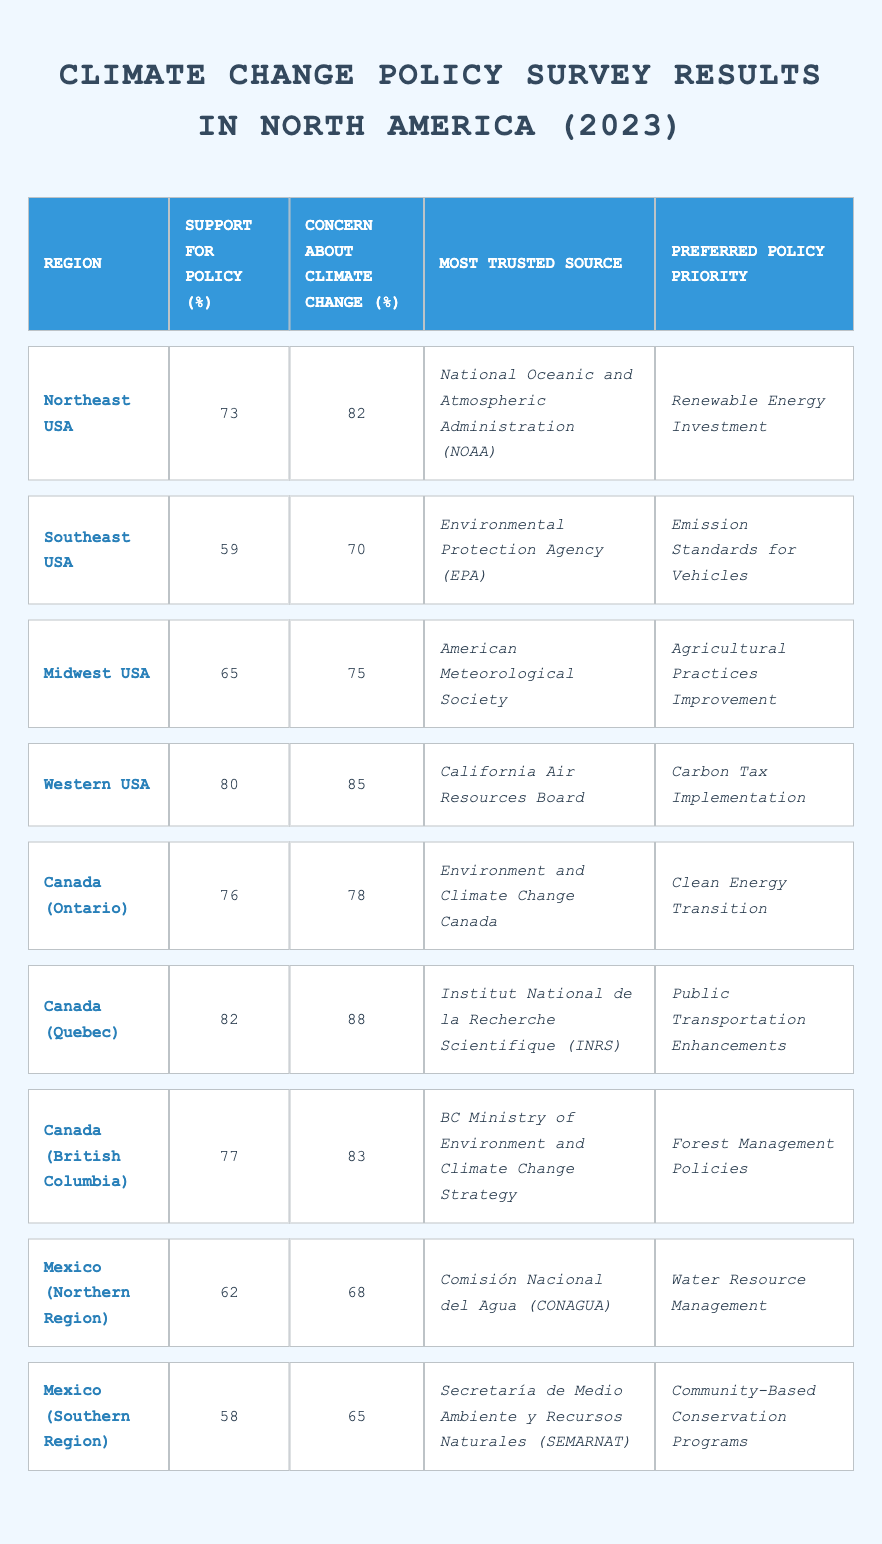What is the support for climate change policy in the Western USA? The table indicates that the support for policy in the Western USA is 80%.
Answer: 80% Which region has the highest concern about climate change? By examining the table, Quebec has the highest concern at 88%.
Answer: Quebec What is the average support for climate change policies across all regions? To find the average, sum the support values (73 + 59 + 65 + 80 + 76 + 82 + 77 + 62 + 58) =  672. There are 9 regions, so the average is 672/9 ≈ 74.67.
Answer: 74.67 In which region is the Environmental Protection Agency (EPA) the most trusted source? The EPA is the most trusted source in the Southeast USA, according to the table.
Answer: Southeast USA How many regions reported a support for policy below 70%? According to the table, the Southeast USA (59%), Mexico (Southern Region) (58%), and Mexico (Northern Region) (62%) are below 70%, totaling 3 regions.
Answer: 3 Is the preferred policy priority for the Midwest USA focused on renewable energy? The Midwest USA's preferred policy priority is "Agricultural Practices Improvement," which is not focused on renewable energy.
Answer: No What is the difference between the concern about climate change in Quebec and the concern in the Southern Region of Mexico? The concern in Quebec is 88%, and in the Southern Region of Mexico, it is 65%. The difference is 88 - 65 = 23.
Answer: 23 Which region has the lowest support for climate change policies? By checking the table, the region with the lowest support is the Southern Region of Mexico with 58%.
Answer: Southern Region of Mexico What percentage of respondents in the Midwest USA expressed concern about climate change? The Midwest USA shows a concern level of 75% in the table.
Answer: 75% Is the most trusted source in Ontario the same as in Quebec? The most trusted source in Ontario is "Environment and Climate Change Canada," while in Quebec it is "Institut National de la Recherche Scientifique (INRS)," so they are not the same.
Answer: No Which region prefers "Public Transportation Enhancements" as the policy priority? The table states that Canada (Quebec) prefers "Public Transportation Enhancements."
Answer: Canada (Quebec) 